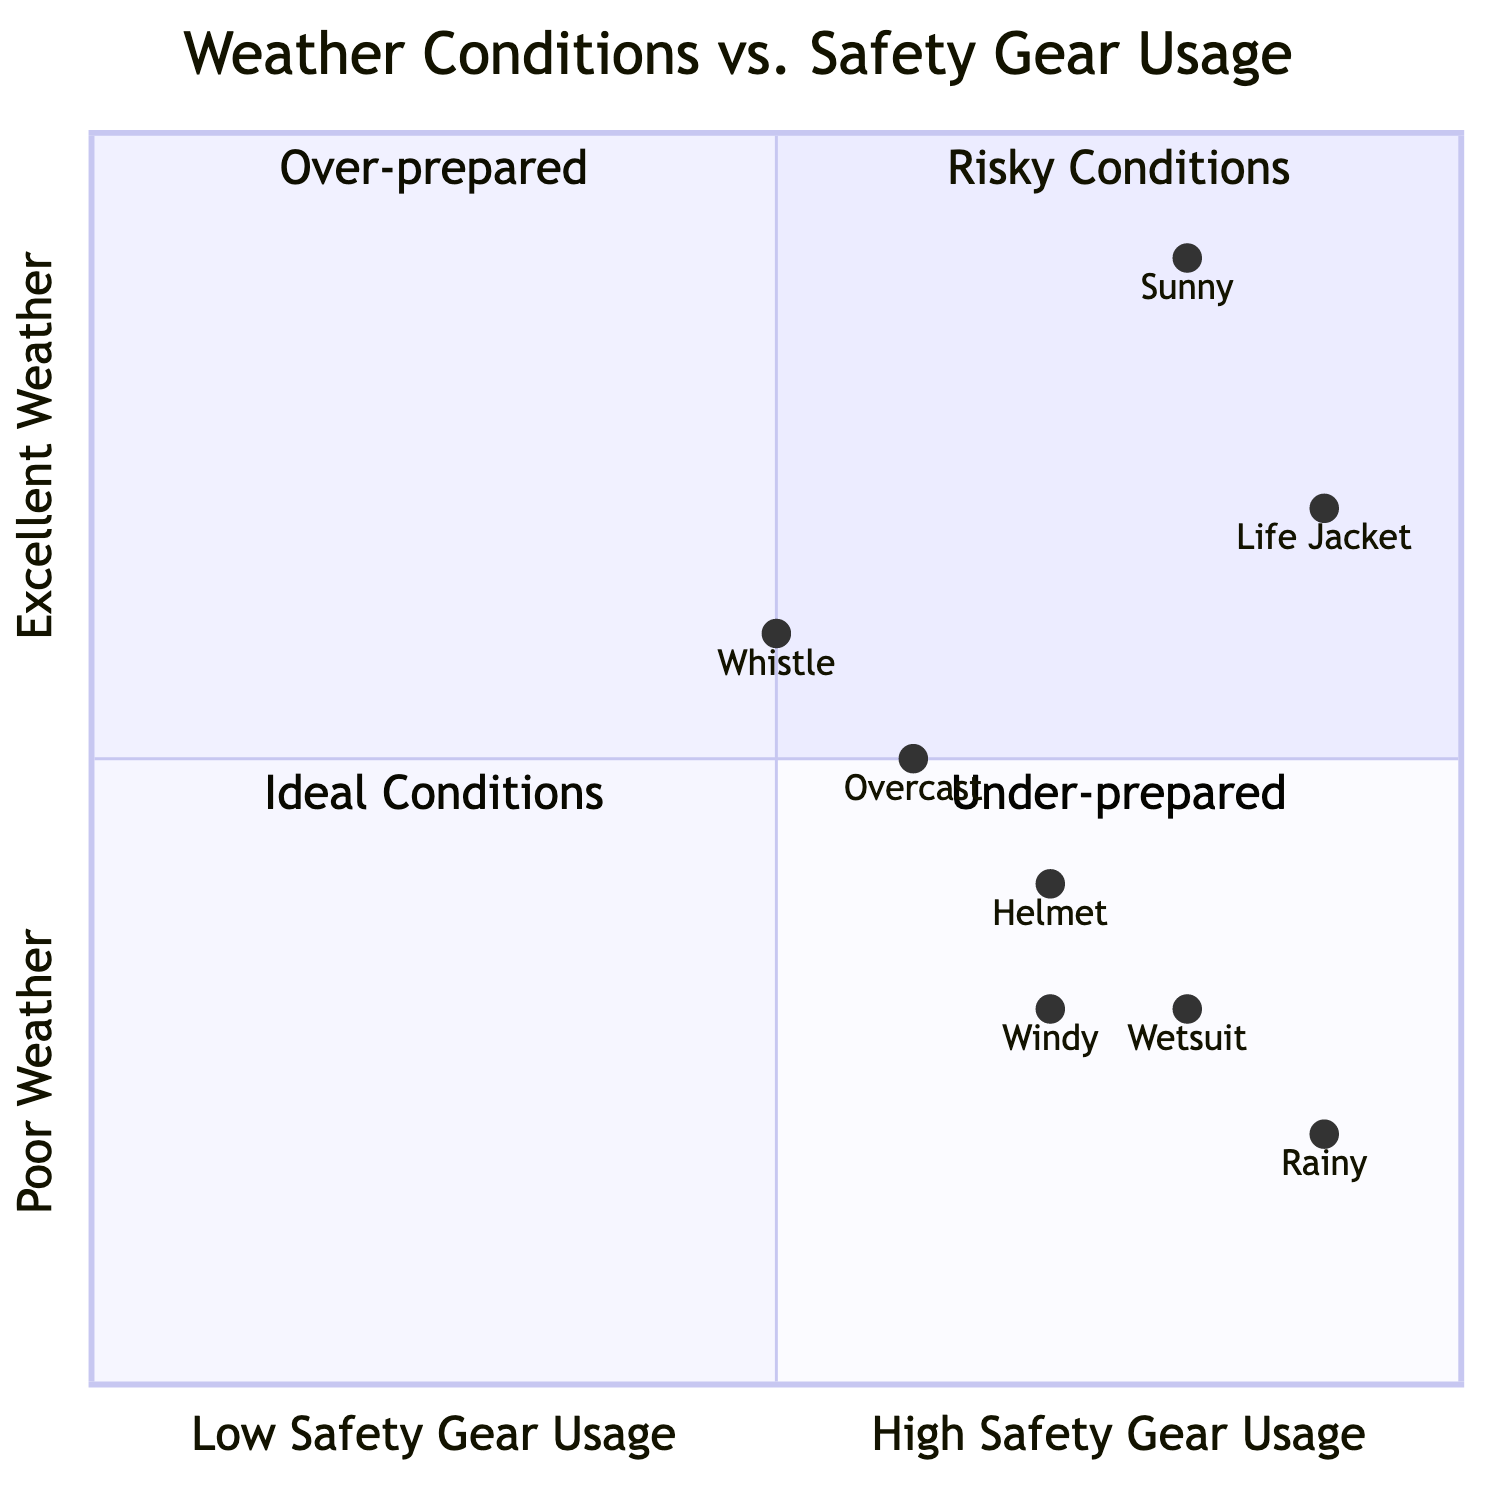What weather condition corresponds to the highest safety gear usage? The diagram displays safety gear usage for various weather conditions, with the highest usage found in "Rainy" conditions, as seen by its position in the quadrant chart, which indicates significant safety gear involvement.
Answer: Rainy Which distance paddled shows the most enjoyment according to the diagram? The diagram does not directly indicate distance paddled, but one can infer that distance paddled in "Sunny" weather might correlate with higher enjoyment levels. Therefore, while there is no exact correlation shown, it suggests that shorter distances in ideal conditions yield enjoyment.
Answer: 1-3 miles Which quadrant contains conditions where safety gear usage is low? The quadrant chart classifies "Risky Conditions" as a quadrant where low safety gear usage intersects with poor weather conditions, thus showing that conditions in this quadrant relate to low safety gear usage.
Answer: Risky Conditions In which quadrant are paddlers considered over-prepared? The quadrant labeled "Over-prepared" represents where conditions correlate with high safety gear usage in excellent weather which means paddlers are using more gear than necessary.
Answer: Over-prepared What is the safety gear usage level when paddling in windy conditions? To determine safety gear usage for "Windy" conditions, we look at the placement in the quadrant chart and find a value of 0.7 on the safety gear axis, indicating a moderate level of usage.
Answer: 0.7 